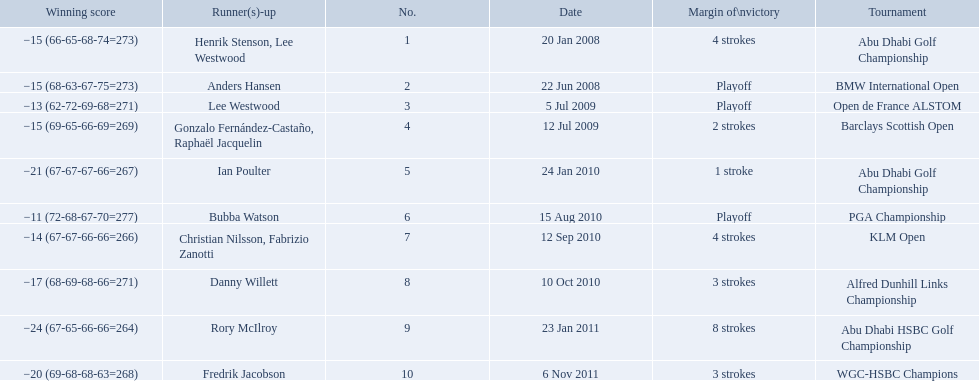What were the margins of victories of the tournaments? 4 strokes, Playoff, Playoff, 2 strokes, 1 stroke, Playoff, 4 strokes, 3 strokes, 8 strokes, 3 strokes. Of these, what was the margin of victory of the klm and the barklay 2 strokes, 4 strokes. What were the difference between these? 2 strokes. 